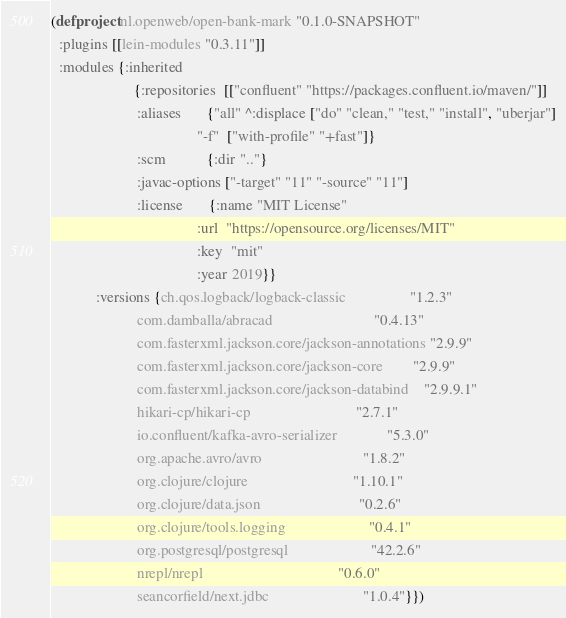Convert code to text. <code><loc_0><loc_0><loc_500><loc_500><_Clojure_>(defproject nl.openweb/open-bank-mark "0.1.0-SNAPSHOT"
  :plugins [[lein-modules "0.3.11"]]
  :modules {:inherited
                      {:repositories  [["confluent" "https://packages.confluent.io/maven/"]]
                       :aliases       {"all" ^:displace ["do" "clean," "test," "install", "uberjar"]
                                       "-f"  ["with-profile" "+fast"]}
                       :scm           {:dir ".."}
                       :javac-options ["-target" "11" "-source" "11"]
                       :license       {:name "MIT License"
                                       :url  "https://opensource.org/licenses/MIT"
                                       :key  "mit"
                                       :year 2019}}
            :versions {ch.qos.logback/logback-classic                 "1.2.3"
                       com.damballa/abracad                           "0.4.13"
                       com.fasterxml.jackson.core/jackson-annotations "2.9.9"
                       com.fasterxml.jackson.core/jackson-core        "2.9.9"
                       com.fasterxml.jackson.core/jackson-databind    "2.9.9.1"
                       hikari-cp/hikari-cp                            "2.7.1"
                       io.confluent/kafka-avro-serializer             "5.3.0"
                       org.apache.avro/avro                           "1.8.2"
                       org.clojure/clojure                            "1.10.1"
                       org.clojure/data.json                          "0.2.6"
                       org.clojure/tools.logging                      "0.4.1"
                       org.postgresql/postgresql                      "42.2.6"
                       nrepl/nrepl                                    "0.6.0"
                       seancorfield/next.jdbc                         "1.0.4"}})
</code> 